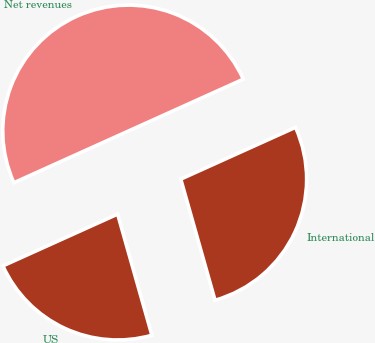<chart> <loc_0><loc_0><loc_500><loc_500><pie_chart><fcel>US<fcel>International<fcel>Net revenues<nl><fcel>22.64%<fcel>27.36%<fcel>50.0%<nl></chart> 